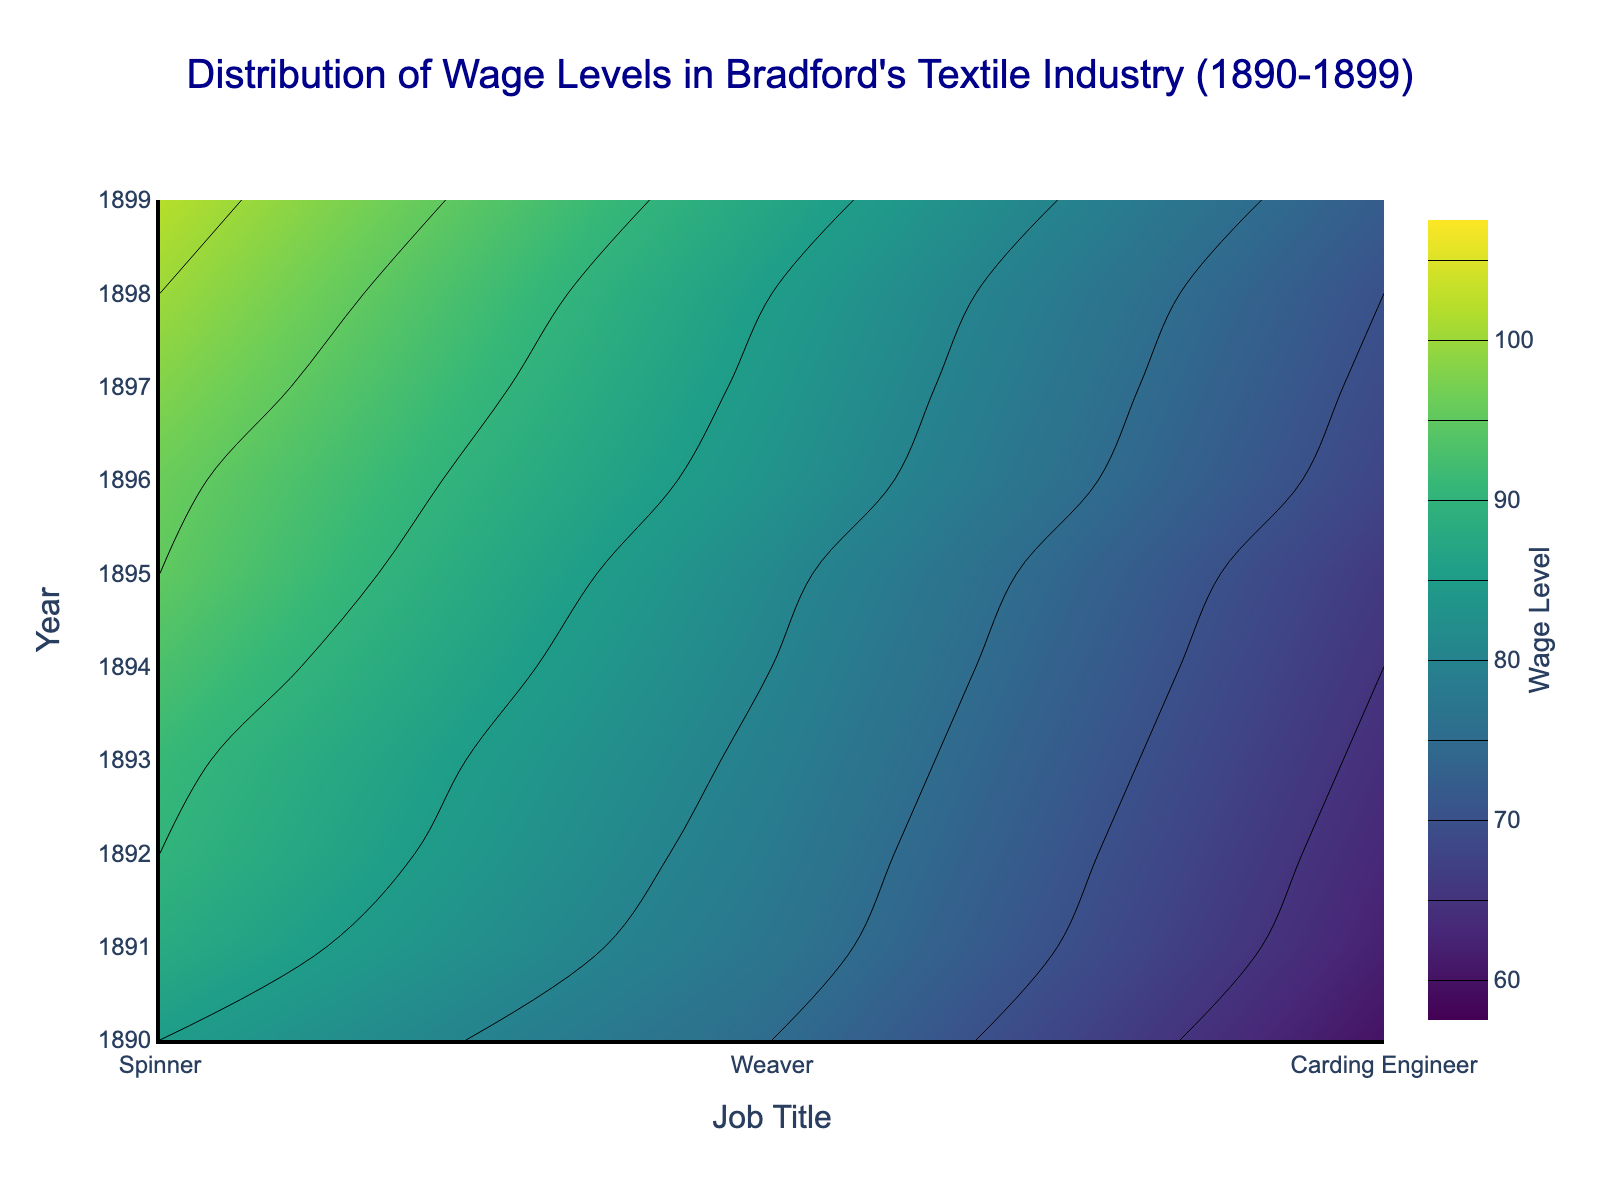what is the title of the figure? The title is located at the top-center of the figure in a slightly larger and dark blue font. It clearly describes the main topic of the figure.
Answer: Distribution of Wage Levels in Bradford's Textile Industry (1890-1899) Which job title had the highest wage level in 1899? Observe the contour plot's heatmap color gradient for the year 1899 and identify the job title corresponding to the highest wage level. The darkest region indicates the highest value.
Answer: Carding Engineer What is the wage level range depicted in the colorbar? Examine the colorbar on the right side of the figure. It illustrates the wage levels from the start to the end value, indicated by the ticks and labels.
Answer: 60 to 105 How did the wage level for Spinners change from 1890 to 1899? Look at the heatmap contour values for Spinners over the years from 1890 to 1899. Note the trend and any changes in the associated colors indicating wage levels over time.
Answer: Increased from 75 to 87 What's the average wage level for Weavers across the decade? Sum the wage levels for Weavers for each year from 1890 to 1899, then divide by the number of years (10) to get the average. 60 + 62 + 63 + 64 + 65 + 66 + 68 + 69 + 70 + 72 = 659. Average = 659 / 10 = 65.9
Answer: 65.9 Between Spinners and Weavers, which job title had a higher increase in wage level from 1890 to 1899? Calculate the difference in wage levels for both job titles between 1890 and 1899. For Spinners: 87 - 75 = 12. For Weavers: 72 - 60 = 12. Compare the differences.
Answer: Both had the same increase Which year showed the greatest increase in wage level for Carding Engineers compared to the previous year? Check the year-over-year increase for Carding Engineers by subtracting the previous year's wage level from the current year's wage level for each year. Identify the year with the largest difference.
Answer: 1896 (Difference: 96 - 95 = 5) What wage level is represented by the brightest green color on the contour plot? Identify the shade of green that appears the brightest and refer to the colorbar to determine the corresponding wage level.
Answer: 85 Which job title experienced the least overall change in wage levels throughout the decade? Compare the net change in wage levels from 1890 to 1899 for each job title. The job title with the smallest absolute difference had the least change. Weaver: 72 - 60 = 12, Spinner: 87 - 75 = 12, Carding Engineer: 102 - 85 = 17.
Answer: Weaver 